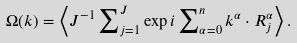Convert formula to latex. <formula><loc_0><loc_0><loc_500><loc_500>\Omega ( k ) = \left \langle J ^ { - 1 } \sum \nolimits _ { j = 1 } ^ { J } \exp i \sum \nolimits _ { \alpha = 0 } ^ { n } { k } ^ { \alpha } \cdot { R } _ { j } ^ { \alpha } \right \rangle .</formula> 